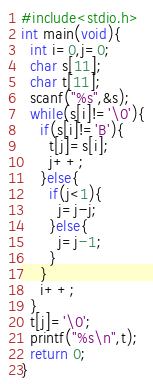Convert code to text. <code><loc_0><loc_0><loc_500><loc_500><_C_>#include<stdio.h>
int main(void){
  int i=0,j=0;
  char s[11];
  char t[11];
  scanf("%s",&s);
  while(s[i]!='\0'){
    if(s[i]!='B'){
      t[j]=s[i];
      j++;
    }else{
      if(j<1){
        j=j-j;
      }else{
        j=j-1;
      }
    }
    i++;
  }
  t[j]='\0';
  printf("%s\n",t);
  return 0;
}</code> 